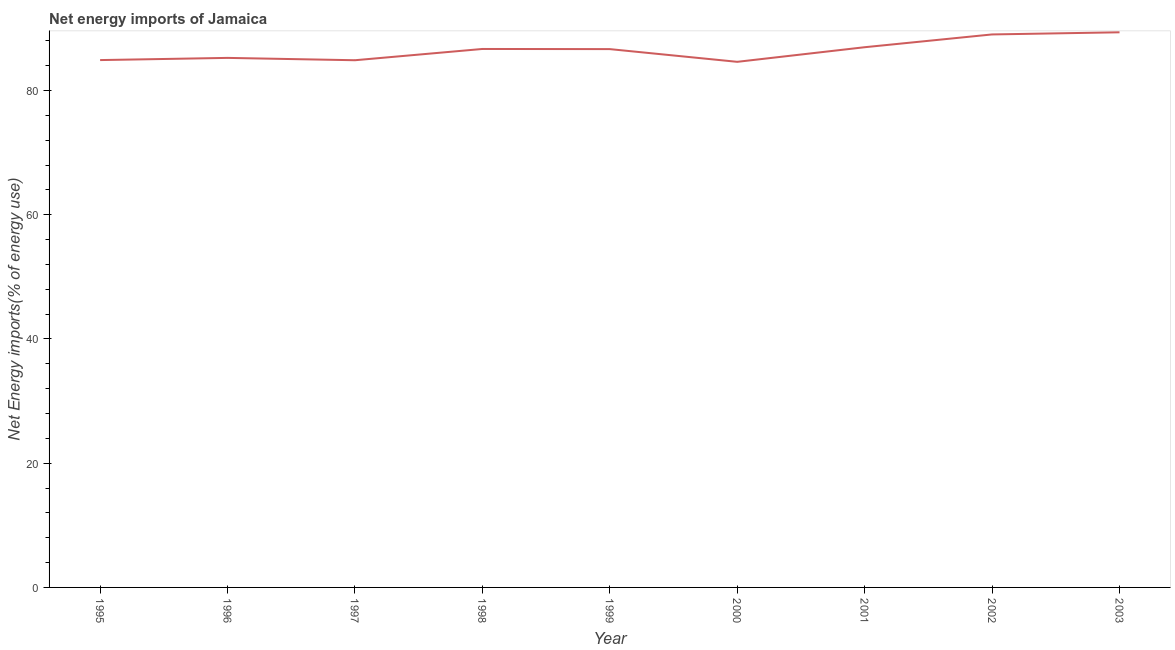What is the energy imports in 2002?
Your response must be concise. 89.03. Across all years, what is the maximum energy imports?
Keep it short and to the point. 89.38. Across all years, what is the minimum energy imports?
Make the answer very short. 84.62. In which year was the energy imports minimum?
Offer a terse response. 2000. What is the sum of the energy imports?
Provide a short and direct response. 778.4. What is the difference between the energy imports in 1995 and 1999?
Your response must be concise. -1.76. What is the average energy imports per year?
Ensure brevity in your answer.  86.49. What is the median energy imports?
Keep it short and to the point. 86.67. Do a majority of the years between 1997 and 2000 (inclusive) have energy imports greater than 24 %?
Keep it short and to the point. Yes. What is the ratio of the energy imports in 2000 to that in 2003?
Provide a short and direct response. 0.95. Is the energy imports in 1996 less than that in 2003?
Offer a terse response. Yes. What is the difference between the highest and the second highest energy imports?
Make the answer very short. 0.34. What is the difference between the highest and the lowest energy imports?
Your response must be concise. 4.75. How many years are there in the graph?
Your answer should be very brief. 9. What is the difference between two consecutive major ticks on the Y-axis?
Offer a very short reply. 20. Are the values on the major ticks of Y-axis written in scientific E-notation?
Ensure brevity in your answer.  No. What is the title of the graph?
Your response must be concise. Net energy imports of Jamaica. What is the label or title of the X-axis?
Keep it short and to the point. Year. What is the label or title of the Y-axis?
Your answer should be compact. Net Energy imports(% of energy use). What is the Net Energy imports(% of energy use) of 1995?
Keep it short and to the point. 84.9. What is the Net Energy imports(% of energy use) of 1996?
Offer a terse response. 85.26. What is the Net Energy imports(% of energy use) of 1997?
Keep it short and to the point. 84.88. What is the Net Energy imports(% of energy use) of 1998?
Your answer should be compact. 86.69. What is the Net Energy imports(% of energy use) of 1999?
Ensure brevity in your answer.  86.67. What is the Net Energy imports(% of energy use) of 2000?
Provide a succinct answer. 84.62. What is the Net Energy imports(% of energy use) of 2001?
Make the answer very short. 86.97. What is the Net Energy imports(% of energy use) in 2002?
Your answer should be compact. 89.03. What is the Net Energy imports(% of energy use) of 2003?
Your answer should be very brief. 89.38. What is the difference between the Net Energy imports(% of energy use) in 1995 and 1996?
Keep it short and to the point. -0.35. What is the difference between the Net Energy imports(% of energy use) in 1995 and 1997?
Make the answer very short. 0.03. What is the difference between the Net Energy imports(% of energy use) in 1995 and 1998?
Offer a terse response. -1.79. What is the difference between the Net Energy imports(% of energy use) in 1995 and 1999?
Keep it short and to the point. -1.76. What is the difference between the Net Energy imports(% of energy use) in 1995 and 2000?
Provide a short and direct response. 0.28. What is the difference between the Net Energy imports(% of energy use) in 1995 and 2001?
Ensure brevity in your answer.  -2.07. What is the difference between the Net Energy imports(% of energy use) in 1995 and 2002?
Provide a short and direct response. -4.13. What is the difference between the Net Energy imports(% of energy use) in 1995 and 2003?
Offer a very short reply. -4.47. What is the difference between the Net Energy imports(% of energy use) in 1996 and 1997?
Offer a very short reply. 0.38. What is the difference between the Net Energy imports(% of energy use) in 1996 and 1998?
Make the answer very short. -1.44. What is the difference between the Net Energy imports(% of energy use) in 1996 and 1999?
Offer a very short reply. -1.41. What is the difference between the Net Energy imports(% of energy use) in 1996 and 2000?
Give a very brief answer. 0.63. What is the difference between the Net Energy imports(% of energy use) in 1996 and 2001?
Your answer should be very brief. -1.72. What is the difference between the Net Energy imports(% of energy use) in 1996 and 2002?
Provide a succinct answer. -3.78. What is the difference between the Net Energy imports(% of energy use) in 1996 and 2003?
Provide a short and direct response. -4.12. What is the difference between the Net Energy imports(% of energy use) in 1997 and 1998?
Offer a very short reply. -1.82. What is the difference between the Net Energy imports(% of energy use) in 1997 and 1999?
Offer a very short reply. -1.79. What is the difference between the Net Energy imports(% of energy use) in 1997 and 2000?
Your response must be concise. 0.26. What is the difference between the Net Energy imports(% of energy use) in 1997 and 2001?
Offer a terse response. -2.1. What is the difference between the Net Energy imports(% of energy use) in 1997 and 2002?
Offer a very short reply. -4.15. What is the difference between the Net Energy imports(% of energy use) in 1997 and 2003?
Make the answer very short. -4.5. What is the difference between the Net Energy imports(% of energy use) in 1998 and 1999?
Your response must be concise. 0.02. What is the difference between the Net Energy imports(% of energy use) in 1998 and 2000?
Your answer should be compact. 2.07. What is the difference between the Net Energy imports(% of energy use) in 1998 and 2001?
Offer a terse response. -0.28. What is the difference between the Net Energy imports(% of energy use) in 1998 and 2002?
Your response must be concise. -2.34. What is the difference between the Net Energy imports(% of energy use) in 1998 and 2003?
Ensure brevity in your answer.  -2.68. What is the difference between the Net Energy imports(% of energy use) in 1999 and 2000?
Your response must be concise. 2.05. What is the difference between the Net Energy imports(% of energy use) in 1999 and 2001?
Provide a succinct answer. -0.31. What is the difference between the Net Energy imports(% of energy use) in 1999 and 2002?
Your answer should be very brief. -2.36. What is the difference between the Net Energy imports(% of energy use) in 1999 and 2003?
Provide a short and direct response. -2.71. What is the difference between the Net Energy imports(% of energy use) in 2000 and 2001?
Keep it short and to the point. -2.35. What is the difference between the Net Energy imports(% of energy use) in 2000 and 2002?
Provide a succinct answer. -4.41. What is the difference between the Net Energy imports(% of energy use) in 2000 and 2003?
Ensure brevity in your answer.  -4.75. What is the difference between the Net Energy imports(% of energy use) in 2001 and 2002?
Your answer should be compact. -2.06. What is the difference between the Net Energy imports(% of energy use) in 2001 and 2003?
Your answer should be very brief. -2.4. What is the difference between the Net Energy imports(% of energy use) in 2002 and 2003?
Ensure brevity in your answer.  -0.34. What is the ratio of the Net Energy imports(% of energy use) in 1995 to that in 2000?
Keep it short and to the point. 1. What is the ratio of the Net Energy imports(% of energy use) in 1995 to that in 2001?
Your answer should be very brief. 0.98. What is the ratio of the Net Energy imports(% of energy use) in 1995 to that in 2002?
Offer a terse response. 0.95. What is the ratio of the Net Energy imports(% of energy use) in 1996 to that in 1998?
Provide a succinct answer. 0.98. What is the ratio of the Net Energy imports(% of energy use) in 1996 to that in 2000?
Offer a terse response. 1.01. What is the ratio of the Net Energy imports(% of energy use) in 1996 to that in 2001?
Provide a succinct answer. 0.98. What is the ratio of the Net Energy imports(% of energy use) in 1996 to that in 2002?
Your response must be concise. 0.96. What is the ratio of the Net Energy imports(% of energy use) in 1996 to that in 2003?
Ensure brevity in your answer.  0.95. What is the ratio of the Net Energy imports(% of energy use) in 1997 to that in 2000?
Your response must be concise. 1. What is the ratio of the Net Energy imports(% of energy use) in 1997 to that in 2001?
Offer a very short reply. 0.98. What is the ratio of the Net Energy imports(% of energy use) in 1997 to that in 2002?
Offer a terse response. 0.95. What is the ratio of the Net Energy imports(% of energy use) in 1997 to that in 2003?
Give a very brief answer. 0.95. What is the ratio of the Net Energy imports(% of energy use) in 1998 to that in 1999?
Provide a succinct answer. 1. What is the ratio of the Net Energy imports(% of energy use) in 1998 to that in 2000?
Your response must be concise. 1.02. What is the ratio of the Net Energy imports(% of energy use) in 1998 to that in 2002?
Offer a very short reply. 0.97. What is the ratio of the Net Energy imports(% of energy use) in 1999 to that in 2000?
Give a very brief answer. 1.02. What is the ratio of the Net Energy imports(% of energy use) in 1999 to that in 2001?
Your answer should be very brief. 1. What is the ratio of the Net Energy imports(% of energy use) in 1999 to that in 2002?
Your answer should be very brief. 0.97. What is the ratio of the Net Energy imports(% of energy use) in 2000 to that in 2002?
Make the answer very short. 0.95. What is the ratio of the Net Energy imports(% of energy use) in 2000 to that in 2003?
Ensure brevity in your answer.  0.95. What is the ratio of the Net Energy imports(% of energy use) in 2001 to that in 2003?
Provide a succinct answer. 0.97. What is the ratio of the Net Energy imports(% of energy use) in 2002 to that in 2003?
Provide a short and direct response. 1. 